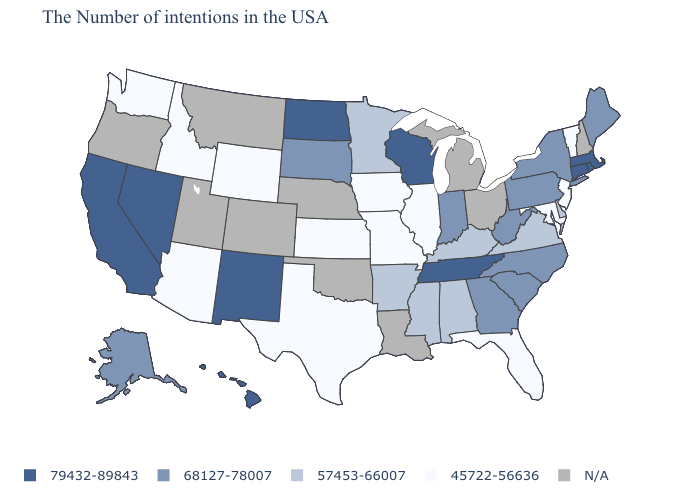Which states hav the highest value in the South?
Short answer required. Tennessee. Does New Mexico have the lowest value in the West?
Quick response, please. No. Which states hav the highest value in the MidWest?
Concise answer only. Wisconsin, North Dakota. How many symbols are there in the legend?
Quick response, please. 5. Name the states that have a value in the range 57453-66007?
Write a very short answer. Delaware, Virginia, Kentucky, Alabama, Mississippi, Arkansas, Minnesota. Does Washington have the lowest value in the USA?
Quick response, please. Yes. What is the value of North Carolina?
Concise answer only. 68127-78007. How many symbols are there in the legend?
Answer briefly. 5. What is the value of Delaware?
Keep it brief. 57453-66007. What is the lowest value in the South?
Short answer required. 45722-56636. Among the states that border Vermont , which have the highest value?
Short answer required. Massachusetts. Name the states that have a value in the range N/A?
Keep it brief. New Hampshire, Ohio, Michigan, Louisiana, Nebraska, Oklahoma, Colorado, Utah, Montana, Oregon. Name the states that have a value in the range 57453-66007?
Be succinct. Delaware, Virginia, Kentucky, Alabama, Mississippi, Arkansas, Minnesota. What is the value of Mississippi?
Answer briefly. 57453-66007. Name the states that have a value in the range 68127-78007?
Keep it brief. Maine, New York, Pennsylvania, North Carolina, South Carolina, West Virginia, Georgia, Indiana, South Dakota, Alaska. 